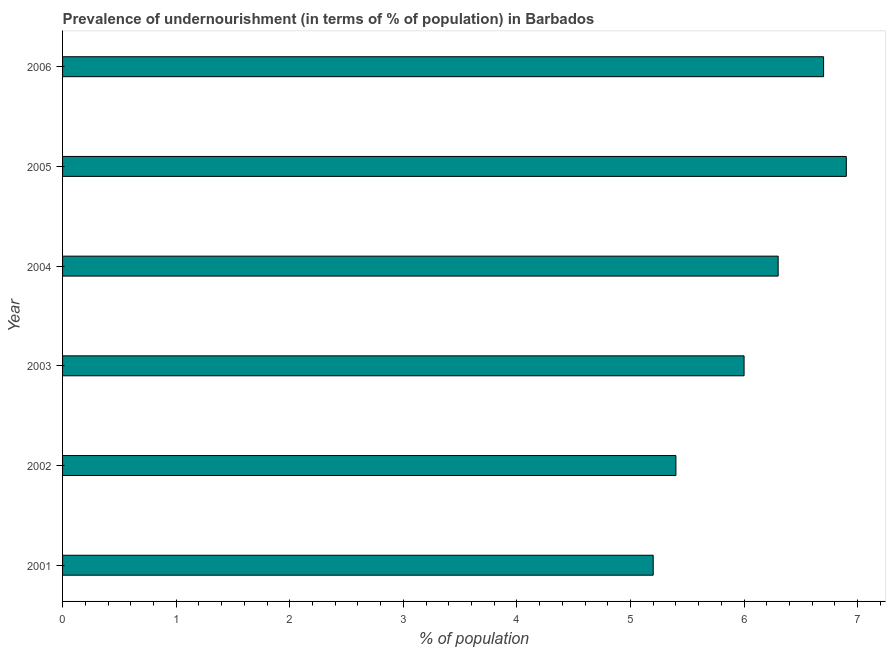What is the title of the graph?
Your response must be concise. Prevalence of undernourishment (in terms of % of population) in Barbados. What is the label or title of the X-axis?
Keep it short and to the point. % of population. What is the percentage of undernourished population in 2002?
Offer a very short reply. 5.4. Across all years, what is the maximum percentage of undernourished population?
Offer a very short reply. 6.9. Across all years, what is the minimum percentage of undernourished population?
Your response must be concise. 5.2. What is the sum of the percentage of undernourished population?
Make the answer very short. 36.5. What is the difference between the percentage of undernourished population in 2001 and 2002?
Offer a very short reply. -0.2. What is the average percentage of undernourished population per year?
Provide a short and direct response. 6.08. What is the median percentage of undernourished population?
Offer a terse response. 6.15. In how many years, is the percentage of undernourished population greater than 2.8 %?
Offer a very short reply. 6. What is the difference between the highest and the lowest percentage of undernourished population?
Ensure brevity in your answer.  1.7. In how many years, is the percentage of undernourished population greater than the average percentage of undernourished population taken over all years?
Provide a short and direct response. 3. How many years are there in the graph?
Offer a terse response. 6. What is the difference between two consecutive major ticks on the X-axis?
Provide a short and direct response. 1. What is the % of population in 2001?
Offer a terse response. 5.2. What is the % of population in 2003?
Your answer should be very brief. 6. What is the % of population in 2004?
Your answer should be very brief. 6.3. What is the % of population of 2005?
Ensure brevity in your answer.  6.9. What is the % of population of 2006?
Your response must be concise. 6.7. What is the difference between the % of population in 2001 and 2003?
Your answer should be compact. -0.8. What is the difference between the % of population in 2001 and 2004?
Your answer should be very brief. -1.1. What is the difference between the % of population in 2001 and 2005?
Make the answer very short. -1.7. What is the difference between the % of population in 2001 and 2006?
Ensure brevity in your answer.  -1.5. What is the difference between the % of population in 2002 and 2003?
Keep it short and to the point. -0.6. What is the difference between the % of population in 2002 and 2005?
Keep it short and to the point. -1.5. What is the difference between the % of population in 2004 and 2005?
Your response must be concise. -0.6. What is the difference between the % of population in 2004 and 2006?
Keep it short and to the point. -0.4. What is the ratio of the % of population in 2001 to that in 2002?
Make the answer very short. 0.96. What is the ratio of the % of population in 2001 to that in 2003?
Your answer should be compact. 0.87. What is the ratio of the % of population in 2001 to that in 2004?
Your answer should be very brief. 0.82. What is the ratio of the % of population in 2001 to that in 2005?
Offer a very short reply. 0.75. What is the ratio of the % of population in 2001 to that in 2006?
Your answer should be very brief. 0.78. What is the ratio of the % of population in 2002 to that in 2003?
Your answer should be compact. 0.9. What is the ratio of the % of population in 2002 to that in 2004?
Give a very brief answer. 0.86. What is the ratio of the % of population in 2002 to that in 2005?
Ensure brevity in your answer.  0.78. What is the ratio of the % of population in 2002 to that in 2006?
Your answer should be compact. 0.81. What is the ratio of the % of population in 2003 to that in 2005?
Keep it short and to the point. 0.87. What is the ratio of the % of population in 2003 to that in 2006?
Make the answer very short. 0.9. What is the ratio of the % of population in 2004 to that in 2005?
Keep it short and to the point. 0.91. What is the ratio of the % of population in 2004 to that in 2006?
Offer a very short reply. 0.94. What is the ratio of the % of population in 2005 to that in 2006?
Offer a very short reply. 1.03. 